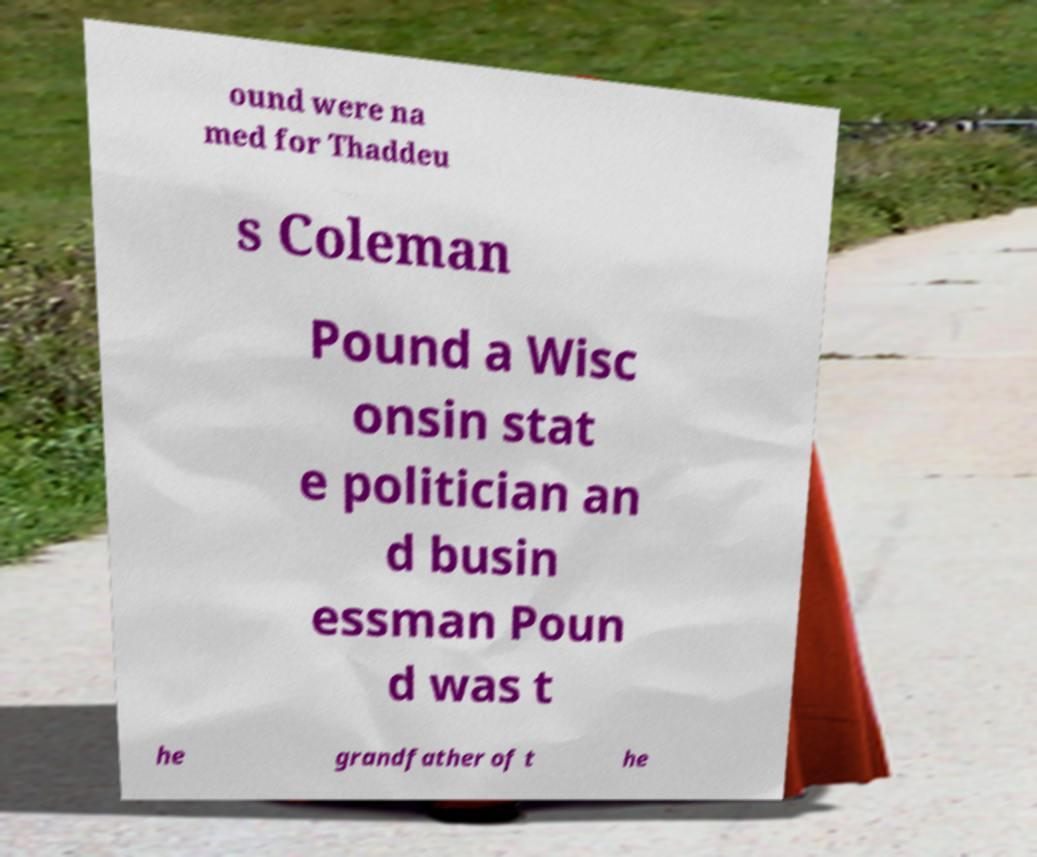Can you accurately transcribe the text from the provided image for me? ound were na med for Thaddeu s Coleman Pound a Wisc onsin stat e politician an d busin essman Poun d was t he grandfather of t he 